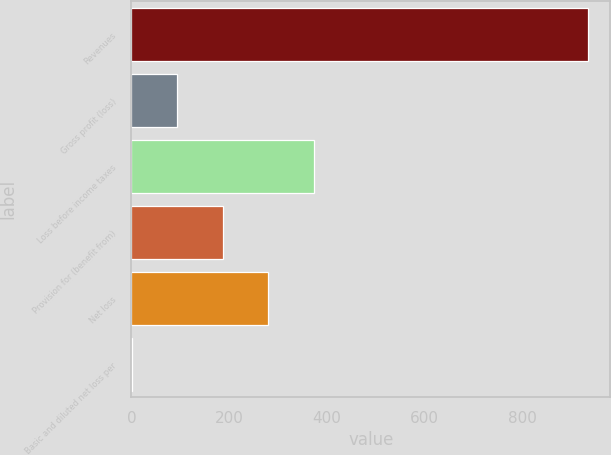<chart> <loc_0><loc_0><loc_500><loc_500><bar_chart><fcel>Revenues<fcel>Gross profit (loss)<fcel>Loss before income taxes<fcel>Provision for (benefit from)<fcel>Net loss<fcel>Basic and diluted net loss per<nl><fcel>932.9<fcel>93.7<fcel>373.44<fcel>186.94<fcel>280.19<fcel>0.45<nl></chart> 